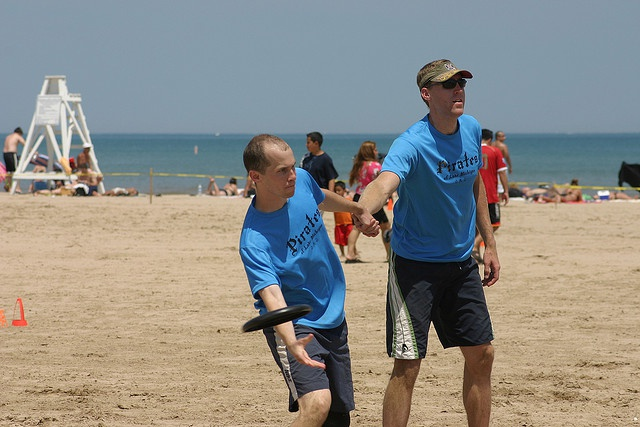Describe the objects in this image and their specific colors. I can see people in darkgray, black, darkblue, blue, and maroon tones, people in darkgray, black, blue, navy, and darkblue tones, people in darkgray, maroon, black, and gray tones, people in darkgray, brown, black, and maroon tones, and people in darkgray, black, maroon, and brown tones in this image. 